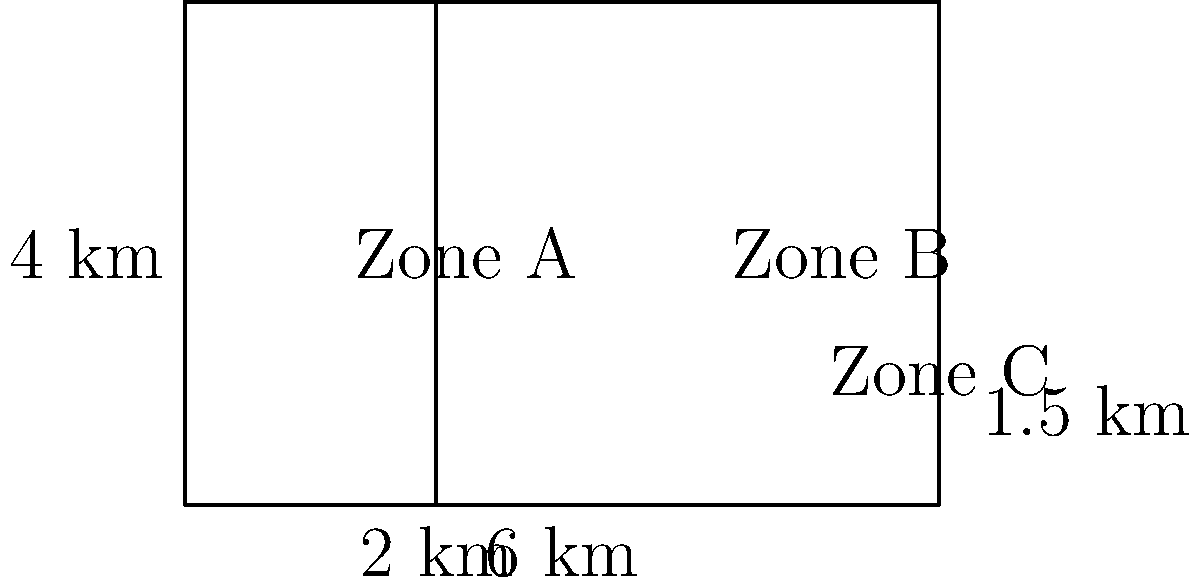In a region affected by desertification, three agricultural zones are being monitored. Zone A is a rectangle measuring 2 km by 4 km. Zone B is also a rectangle, measuring 4 km by 4 km. Zone C is a triangle with a base of 4 km and a height of 1.5 km. Calculate the total area of the three zones and determine what percentage of the total area is represented by Zone C. Let's approach this step-by-step:

1) Calculate the area of Zone A:
   $A_A = 2 \text{ km} \times 4 \text{ km} = 8 \text{ km}^2$

2) Calculate the area of Zone B:
   $A_B = 4 \text{ km} \times 4 \text{ km} = 16 \text{ km}^2$

3) Calculate the area of Zone C (triangle):
   $A_C = \frac{1}{2} \times 4 \text{ km} \times 1.5 \text{ km} = 3 \text{ km}^2$

4) Calculate the total area:
   $A_{\text{total}} = A_A + A_B + A_C = 8 \text{ km}^2 + 16 \text{ km}^2 + 3 \text{ km}^2 = 27 \text{ km}^2$

5) Calculate the percentage of the total area represented by Zone C:
   Percentage = $\frac{A_C}{A_{\text{total}}} \times 100\% = \frac{3 \text{ km}^2}{27 \text{ km}^2} \times 100\% = \frac{1}{9} \times 100\% \approx 11.11\%$
Answer: 27 km²; 11.11% 